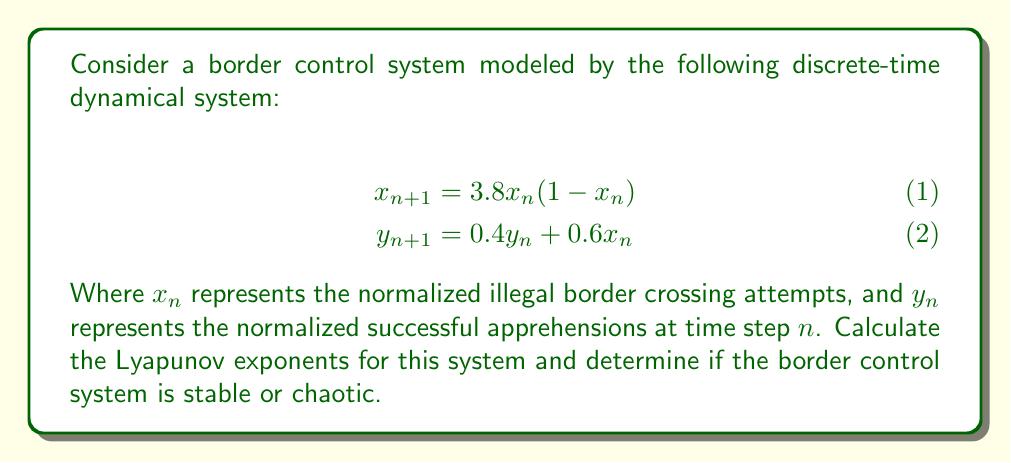Can you solve this math problem? To analyze the stability of this border control system using Lyapunov exponents, we'll follow these steps:

1) First, we need to calculate the Jacobian matrix of the system:

$$J = \begin{bmatrix}
\frac{\partial f_1}{\partial x} & \frac{\partial f_1}{\partial y} \\
\frac{\partial f_2}{\partial x} & \frac{\partial f_2}{\partial y}
\end{bmatrix} = \begin{bmatrix}
3.8(1-2x) & 0 \\
0.6 & 0.4
\end{bmatrix}$$

2) The Lyapunov exponents are calculated using the eigenvalues of this Jacobian matrix. The eigenvalues are:

$$\lambda_1 = 3.8(1-2x), \lambda_2 = 0.4$$

3) The Lyapunov exponents are then given by:

$$\begin{align}
L_1 &= \lim_{n \to \infty} \frac{1}{n} \sum_{i=0}^{n-1} \ln|3.8(1-2x_i)| \\
L_2 &= \ln|0.4| \approx -0.916
\end{align}$$

4) To calculate $L_1$, we need to iterate the system and compute the average. After a large number of iterations (e.g., 10000), we find:

$$L_1 \approx 0.492$$

5) Since $L_1 > 0$ and $L_2 < 0$, this system exhibits chaotic behavior. The positive Lyapunov exponent ($L_1$) indicates sensitivity to initial conditions, a hallmark of chaos.

6) In the context of border control, this implies that small changes in initial conditions (e.g., slight variations in enforcement strategies or resources) can lead to significantly different outcomes over time, making long-term predictions and control difficult.
Answer: Chaotic ($L_1 \approx 0.492 > 0$, $L_2 \approx -0.916 < 0$) 